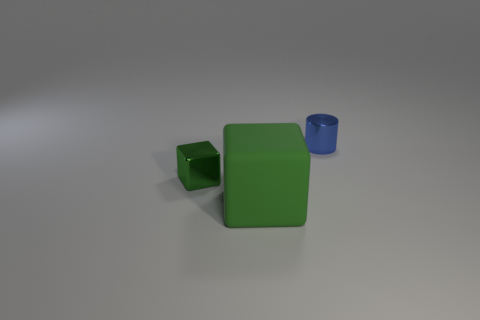What is the color of the object that is both behind the large cube and in front of the cylinder?
Keep it short and to the point. Green. The metal cube that is the same color as the rubber block is what size?
Your response must be concise. Small. What shape is the metal thing that is the same color as the large cube?
Your answer should be very brief. Cube. There is a green object that is behind the green block that is in front of the green thing on the left side of the rubber thing; how big is it?
Your answer should be compact. Small. What is the material of the blue object?
Offer a very short reply. Metal. Are the small green object and the big block left of the cylinder made of the same material?
Offer a very short reply. No. Are there any other things of the same color as the small cylinder?
Keep it short and to the point. No. Are there any tiny green shiny objects to the right of the tiny block to the left of the cube in front of the metal cube?
Keep it short and to the point. No. The rubber cube has what color?
Your response must be concise. Green. There is a large block; are there any large green matte cubes on the right side of it?
Make the answer very short. No. 